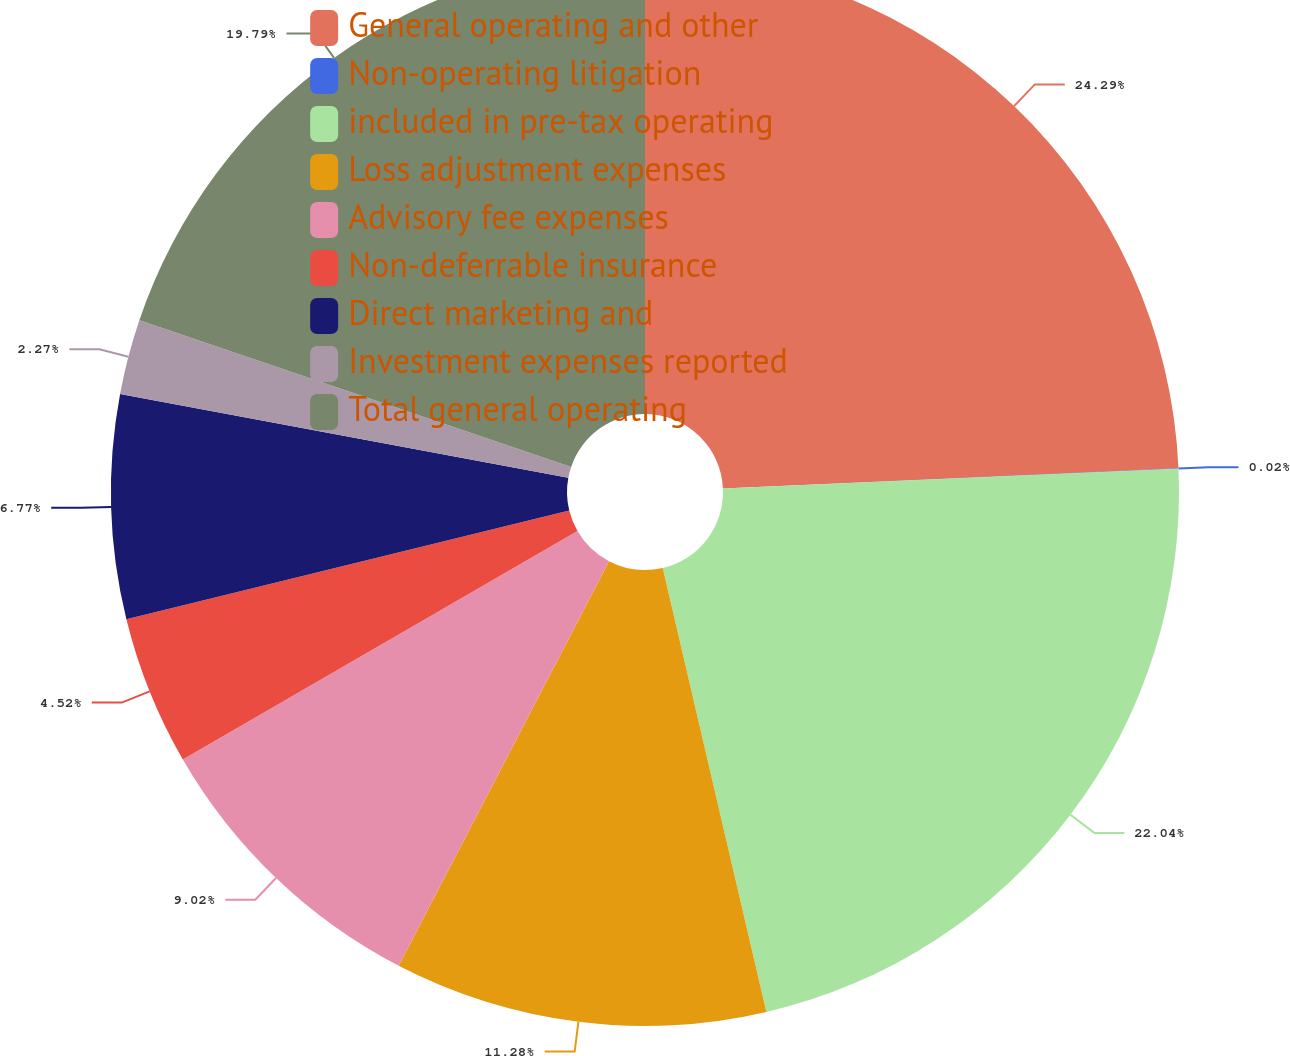Convert chart. <chart><loc_0><loc_0><loc_500><loc_500><pie_chart><fcel>General operating and other<fcel>Non-operating litigation<fcel>included in pre-tax operating<fcel>Loss adjustment expenses<fcel>Advisory fee expenses<fcel>Non-deferrable insurance<fcel>Direct marketing and<fcel>Investment expenses reported<fcel>Total general operating<nl><fcel>24.29%<fcel>0.02%<fcel>22.04%<fcel>11.28%<fcel>9.02%<fcel>4.52%<fcel>6.77%<fcel>2.27%<fcel>19.79%<nl></chart> 